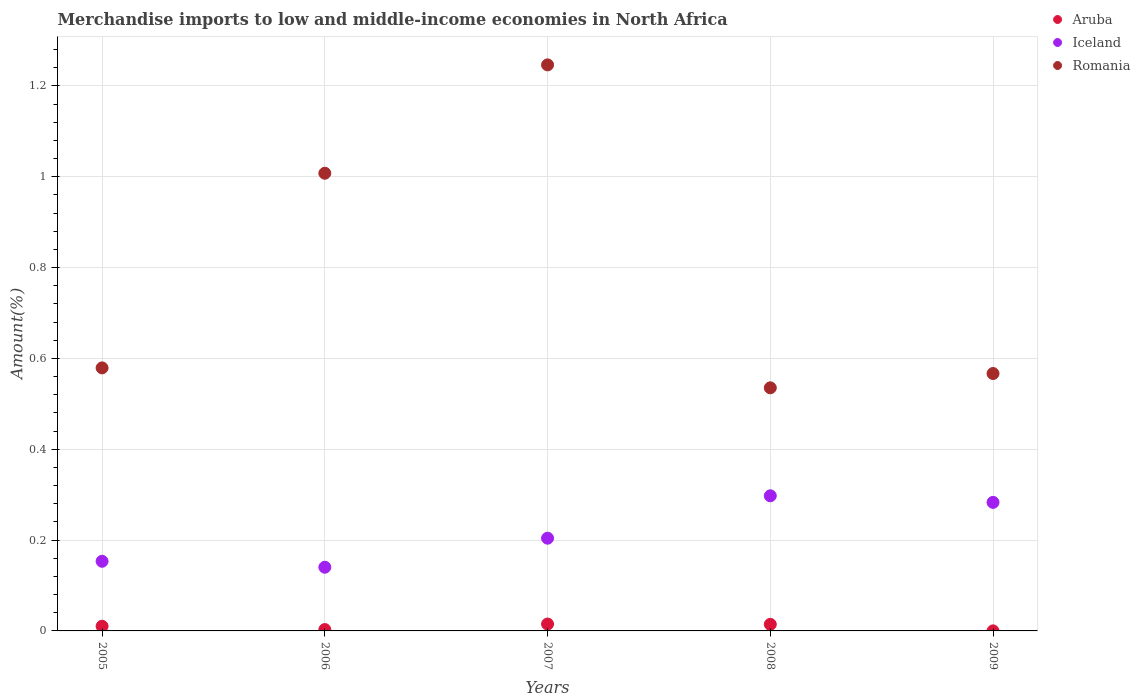How many different coloured dotlines are there?
Provide a short and direct response. 3. Is the number of dotlines equal to the number of legend labels?
Your answer should be very brief. Yes. What is the percentage of amount earned from merchandise imports in Aruba in 2008?
Your answer should be compact. 0.01. Across all years, what is the maximum percentage of amount earned from merchandise imports in Iceland?
Ensure brevity in your answer.  0.3. Across all years, what is the minimum percentage of amount earned from merchandise imports in Aruba?
Keep it short and to the point. 0. In which year was the percentage of amount earned from merchandise imports in Aruba maximum?
Give a very brief answer. 2007. In which year was the percentage of amount earned from merchandise imports in Romania minimum?
Your answer should be compact. 2008. What is the total percentage of amount earned from merchandise imports in Aruba in the graph?
Provide a short and direct response. 0.04. What is the difference between the percentage of amount earned from merchandise imports in Aruba in 2005 and that in 2009?
Your response must be concise. 0.01. What is the difference between the percentage of amount earned from merchandise imports in Iceland in 2006 and the percentage of amount earned from merchandise imports in Romania in 2007?
Your response must be concise. -1.11. What is the average percentage of amount earned from merchandise imports in Romania per year?
Provide a succinct answer. 0.79. In the year 2007, what is the difference between the percentage of amount earned from merchandise imports in Romania and percentage of amount earned from merchandise imports in Aruba?
Keep it short and to the point. 1.23. In how many years, is the percentage of amount earned from merchandise imports in Romania greater than 0.52 %?
Provide a short and direct response. 5. What is the ratio of the percentage of amount earned from merchandise imports in Romania in 2005 to that in 2006?
Provide a short and direct response. 0.57. Is the difference between the percentage of amount earned from merchandise imports in Romania in 2005 and 2007 greater than the difference between the percentage of amount earned from merchandise imports in Aruba in 2005 and 2007?
Give a very brief answer. No. What is the difference between the highest and the second highest percentage of amount earned from merchandise imports in Aruba?
Offer a very short reply. 0. What is the difference between the highest and the lowest percentage of amount earned from merchandise imports in Aruba?
Your answer should be very brief. 0.02. Is the sum of the percentage of amount earned from merchandise imports in Iceland in 2007 and 2008 greater than the maximum percentage of amount earned from merchandise imports in Aruba across all years?
Offer a very short reply. Yes. Is it the case that in every year, the sum of the percentage of amount earned from merchandise imports in Iceland and percentage of amount earned from merchandise imports in Aruba  is greater than the percentage of amount earned from merchandise imports in Romania?
Your answer should be compact. No. Is the percentage of amount earned from merchandise imports in Aruba strictly greater than the percentage of amount earned from merchandise imports in Iceland over the years?
Provide a short and direct response. No. Is the percentage of amount earned from merchandise imports in Romania strictly less than the percentage of amount earned from merchandise imports in Iceland over the years?
Provide a short and direct response. No. How many dotlines are there?
Your answer should be compact. 3. What is the difference between two consecutive major ticks on the Y-axis?
Give a very brief answer. 0.2. Are the values on the major ticks of Y-axis written in scientific E-notation?
Your response must be concise. No. Does the graph contain any zero values?
Offer a terse response. No. Where does the legend appear in the graph?
Make the answer very short. Top right. How are the legend labels stacked?
Make the answer very short. Vertical. What is the title of the graph?
Your response must be concise. Merchandise imports to low and middle-income economies in North Africa. Does "Central African Republic" appear as one of the legend labels in the graph?
Ensure brevity in your answer.  No. What is the label or title of the Y-axis?
Provide a succinct answer. Amount(%). What is the Amount(%) in Aruba in 2005?
Keep it short and to the point. 0.01. What is the Amount(%) of Iceland in 2005?
Your answer should be compact. 0.15. What is the Amount(%) in Romania in 2005?
Ensure brevity in your answer.  0.58. What is the Amount(%) of Aruba in 2006?
Offer a terse response. 0. What is the Amount(%) of Iceland in 2006?
Offer a terse response. 0.14. What is the Amount(%) of Romania in 2006?
Ensure brevity in your answer.  1.01. What is the Amount(%) of Aruba in 2007?
Offer a terse response. 0.02. What is the Amount(%) of Iceland in 2007?
Keep it short and to the point. 0.2. What is the Amount(%) of Romania in 2007?
Your answer should be very brief. 1.25. What is the Amount(%) of Aruba in 2008?
Provide a short and direct response. 0.01. What is the Amount(%) in Iceland in 2008?
Give a very brief answer. 0.3. What is the Amount(%) of Romania in 2008?
Provide a succinct answer. 0.54. What is the Amount(%) in Aruba in 2009?
Give a very brief answer. 0. What is the Amount(%) in Iceland in 2009?
Your answer should be compact. 0.28. What is the Amount(%) in Romania in 2009?
Ensure brevity in your answer.  0.57. Across all years, what is the maximum Amount(%) of Aruba?
Provide a succinct answer. 0.02. Across all years, what is the maximum Amount(%) of Iceland?
Offer a very short reply. 0.3. Across all years, what is the maximum Amount(%) of Romania?
Give a very brief answer. 1.25. Across all years, what is the minimum Amount(%) of Aruba?
Your answer should be compact. 0. Across all years, what is the minimum Amount(%) in Iceland?
Provide a short and direct response. 0.14. Across all years, what is the minimum Amount(%) of Romania?
Offer a terse response. 0.54. What is the total Amount(%) of Aruba in the graph?
Provide a short and direct response. 0.04. What is the total Amount(%) of Iceland in the graph?
Provide a succinct answer. 1.08. What is the total Amount(%) of Romania in the graph?
Your answer should be compact. 3.93. What is the difference between the Amount(%) of Aruba in 2005 and that in 2006?
Give a very brief answer. 0.01. What is the difference between the Amount(%) in Iceland in 2005 and that in 2006?
Your answer should be very brief. 0.01. What is the difference between the Amount(%) in Romania in 2005 and that in 2006?
Provide a succinct answer. -0.43. What is the difference between the Amount(%) in Aruba in 2005 and that in 2007?
Give a very brief answer. -0. What is the difference between the Amount(%) in Iceland in 2005 and that in 2007?
Provide a succinct answer. -0.05. What is the difference between the Amount(%) in Romania in 2005 and that in 2007?
Your answer should be compact. -0.67. What is the difference between the Amount(%) in Aruba in 2005 and that in 2008?
Your response must be concise. -0. What is the difference between the Amount(%) of Iceland in 2005 and that in 2008?
Your answer should be very brief. -0.14. What is the difference between the Amount(%) of Romania in 2005 and that in 2008?
Ensure brevity in your answer.  0.04. What is the difference between the Amount(%) of Aruba in 2005 and that in 2009?
Make the answer very short. 0.01. What is the difference between the Amount(%) of Iceland in 2005 and that in 2009?
Give a very brief answer. -0.13. What is the difference between the Amount(%) in Romania in 2005 and that in 2009?
Make the answer very short. 0.01. What is the difference between the Amount(%) of Aruba in 2006 and that in 2007?
Make the answer very short. -0.01. What is the difference between the Amount(%) of Iceland in 2006 and that in 2007?
Keep it short and to the point. -0.06. What is the difference between the Amount(%) of Romania in 2006 and that in 2007?
Offer a very short reply. -0.24. What is the difference between the Amount(%) of Aruba in 2006 and that in 2008?
Your answer should be compact. -0.01. What is the difference between the Amount(%) of Iceland in 2006 and that in 2008?
Keep it short and to the point. -0.16. What is the difference between the Amount(%) in Romania in 2006 and that in 2008?
Give a very brief answer. 0.47. What is the difference between the Amount(%) of Aruba in 2006 and that in 2009?
Your response must be concise. 0. What is the difference between the Amount(%) of Iceland in 2006 and that in 2009?
Your answer should be very brief. -0.14. What is the difference between the Amount(%) of Romania in 2006 and that in 2009?
Keep it short and to the point. 0.44. What is the difference between the Amount(%) in Aruba in 2007 and that in 2008?
Provide a short and direct response. 0. What is the difference between the Amount(%) of Iceland in 2007 and that in 2008?
Your response must be concise. -0.09. What is the difference between the Amount(%) in Romania in 2007 and that in 2008?
Keep it short and to the point. 0.71. What is the difference between the Amount(%) in Aruba in 2007 and that in 2009?
Provide a short and direct response. 0.02. What is the difference between the Amount(%) in Iceland in 2007 and that in 2009?
Your response must be concise. -0.08. What is the difference between the Amount(%) of Romania in 2007 and that in 2009?
Keep it short and to the point. 0.68. What is the difference between the Amount(%) of Aruba in 2008 and that in 2009?
Give a very brief answer. 0.01. What is the difference between the Amount(%) of Iceland in 2008 and that in 2009?
Provide a short and direct response. 0.01. What is the difference between the Amount(%) in Romania in 2008 and that in 2009?
Ensure brevity in your answer.  -0.03. What is the difference between the Amount(%) of Aruba in 2005 and the Amount(%) of Iceland in 2006?
Offer a very short reply. -0.13. What is the difference between the Amount(%) of Aruba in 2005 and the Amount(%) of Romania in 2006?
Offer a very short reply. -1. What is the difference between the Amount(%) of Iceland in 2005 and the Amount(%) of Romania in 2006?
Your answer should be compact. -0.85. What is the difference between the Amount(%) in Aruba in 2005 and the Amount(%) in Iceland in 2007?
Make the answer very short. -0.19. What is the difference between the Amount(%) in Aruba in 2005 and the Amount(%) in Romania in 2007?
Provide a succinct answer. -1.24. What is the difference between the Amount(%) in Iceland in 2005 and the Amount(%) in Romania in 2007?
Make the answer very short. -1.09. What is the difference between the Amount(%) in Aruba in 2005 and the Amount(%) in Iceland in 2008?
Provide a short and direct response. -0.29. What is the difference between the Amount(%) of Aruba in 2005 and the Amount(%) of Romania in 2008?
Offer a very short reply. -0.52. What is the difference between the Amount(%) of Iceland in 2005 and the Amount(%) of Romania in 2008?
Give a very brief answer. -0.38. What is the difference between the Amount(%) in Aruba in 2005 and the Amount(%) in Iceland in 2009?
Ensure brevity in your answer.  -0.27. What is the difference between the Amount(%) of Aruba in 2005 and the Amount(%) of Romania in 2009?
Offer a very short reply. -0.56. What is the difference between the Amount(%) in Iceland in 2005 and the Amount(%) in Romania in 2009?
Your answer should be very brief. -0.41. What is the difference between the Amount(%) in Aruba in 2006 and the Amount(%) in Iceland in 2007?
Give a very brief answer. -0.2. What is the difference between the Amount(%) in Aruba in 2006 and the Amount(%) in Romania in 2007?
Your answer should be compact. -1.24. What is the difference between the Amount(%) in Iceland in 2006 and the Amount(%) in Romania in 2007?
Provide a short and direct response. -1.11. What is the difference between the Amount(%) of Aruba in 2006 and the Amount(%) of Iceland in 2008?
Your answer should be compact. -0.29. What is the difference between the Amount(%) in Aruba in 2006 and the Amount(%) in Romania in 2008?
Provide a short and direct response. -0.53. What is the difference between the Amount(%) of Iceland in 2006 and the Amount(%) of Romania in 2008?
Make the answer very short. -0.4. What is the difference between the Amount(%) in Aruba in 2006 and the Amount(%) in Iceland in 2009?
Provide a succinct answer. -0.28. What is the difference between the Amount(%) of Aruba in 2006 and the Amount(%) of Romania in 2009?
Offer a terse response. -0.56. What is the difference between the Amount(%) in Iceland in 2006 and the Amount(%) in Romania in 2009?
Offer a very short reply. -0.43. What is the difference between the Amount(%) of Aruba in 2007 and the Amount(%) of Iceland in 2008?
Offer a terse response. -0.28. What is the difference between the Amount(%) of Aruba in 2007 and the Amount(%) of Romania in 2008?
Keep it short and to the point. -0.52. What is the difference between the Amount(%) of Iceland in 2007 and the Amount(%) of Romania in 2008?
Your response must be concise. -0.33. What is the difference between the Amount(%) in Aruba in 2007 and the Amount(%) in Iceland in 2009?
Give a very brief answer. -0.27. What is the difference between the Amount(%) in Aruba in 2007 and the Amount(%) in Romania in 2009?
Your response must be concise. -0.55. What is the difference between the Amount(%) of Iceland in 2007 and the Amount(%) of Romania in 2009?
Keep it short and to the point. -0.36. What is the difference between the Amount(%) of Aruba in 2008 and the Amount(%) of Iceland in 2009?
Your answer should be very brief. -0.27. What is the difference between the Amount(%) in Aruba in 2008 and the Amount(%) in Romania in 2009?
Offer a very short reply. -0.55. What is the difference between the Amount(%) in Iceland in 2008 and the Amount(%) in Romania in 2009?
Offer a terse response. -0.27. What is the average Amount(%) of Aruba per year?
Make the answer very short. 0.01. What is the average Amount(%) of Iceland per year?
Your answer should be compact. 0.22. What is the average Amount(%) of Romania per year?
Provide a succinct answer. 0.79. In the year 2005, what is the difference between the Amount(%) in Aruba and Amount(%) in Iceland?
Your answer should be very brief. -0.14. In the year 2005, what is the difference between the Amount(%) in Aruba and Amount(%) in Romania?
Ensure brevity in your answer.  -0.57. In the year 2005, what is the difference between the Amount(%) in Iceland and Amount(%) in Romania?
Keep it short and to the point. -0.43. In the year 2006, what is the difference between the Amount(%) of Aruba and Amount(%) of Iceland?
Give a very brief answer. -0.14. In the year 2006, what is the difference between the Amount(%) in Aruba and Amount(%) in Romania?
Give a very brief answer. -1. In the year 2006, what is the difference between the Amount(%) in Iceland and Amount(%) in Romania?
Ensure brevity in your answer.  -0.87. In the year 2007, what is the difference between the Amount(%) of Aruba and Amount(%) of Iceland?
Your answer should be very brief. -0.19. In the year 2007, what is the difference between the Amount(%) in Aruba and Amount(%) in Romania?
Your response must be concise. -1.23. In the year 2007, what is the difference between the Amount(%) of Iceland and Amount(%) of Romania?
Ensure brevity in your answer.  -1.04. In the year 2008, what is the difference between the Amount(%) in Aruba and Amount(%) in Iceland?
Keep it short and to the point. -0.28. In the year 2008, what is the difference between the Amount(%) in Aruba and Amount(%) in Romania?
Make the answer very short. -0.52. In the year 2008, what is the difference between the Amount(%) of Iceland and Amount(%) of Romania?
Keep it short and to the point. -0.24. In the year 2009, what is the difference between the Amount(%) of Aruba and Amount(%) of Iceland?
Your answer should be very brief. -0.28. In the year 2009, what is the difference between the Amount(%) of Aruba and Amount(%) of Romania?
Offer a very short reply. -0.57. In the year 2009, what is the difference between the Amount(%) in Iceland and Amount(%) in Romania?
Provide a short and direct response. -0.28. What is the ratio of the Amount(%) in Aruba in 2005 to that in 2006?
Provide a succinct answer. 3.45. What is the ratio of the Amount(%) of Iceland in 2005 to that in 2006?
Keep it short and to the point. 1.09. What is the ratio of the Amount(%) of Romania in 2005 to that in 2006?
Keep it short and to the point. 0.57. What is the ratio of the Amount(%) in Aruba in 2005 to that in 2007?
Provide a short and direct response. 0.68. What is the ratio of the Amount(%) of Iceland in 2005 to that in 2007?
Keep it short and to the point. 0.75. What is the ratio of the Amount(%) in Romania in 2005 to that in 2007?
Give a very brief answer. 0.46. What is the ratio of the Amount(%) in Aruba in 2005 to that in 2008?
Your response must be concise. 0.71. What is the ratio of the Amount(%) of Iceland in 2005 to that in 2008?
Ensure brevity in your answer.  0.52. What is the ratio of the Amount(%) in Romania in 2005 to that in 2008?
Offer a terse response. 1.08. What is the ratio of the Amount(%) of Aruba in 2005 to that in 2009?
Your answer should be compact. 87.95. What is the ratio of the Amount(%) in Iceland in 2005 to that in 2009?
Make the answer very short. 0.54. What is the ratio of the Amount(%) in Romania in 2005 to that in 2009?
Give a very brief answer. 1.02. What is the ratio of the Amount(%) in Aruba in 2006 to that in 2007?
Offer a very short reply. 0.2. What is the ratio of the Amount(%) of Iceland in 2006 to that in 2007?
Your response must be concise. 0.69. What is the ratio of the Amount(%) in Romania in 2006 to that in 2007?
Your response must be concise. 0.81. What is the ratio of the Amount(%) of Aruba in 2006 to that in 2008?
Give a very brief answer. 0.21. What is the ratio of the Amount(%) in Iceland in 2006 to that in 2008?
Your answer should be compact. 0.47. What is the ratio of the Amount(%) of Romania in 2006 to that in 2008?
Offer a terse response. 1.88. What is the ratio of the Amount(%) in Aruba in 2006 to that in 2009?
Your answer should be very brief. 25.47. What is the ratio of the Amount(%) in Iceland in 2006 to that in 2009?
Ensure brevity in your answer.  0.5. What is the ratio of the Amount(%) of Romania in 2006 to that in 2009?
Offer a very short reply. 1.78. What is the ratio of the Amount(%) in Aruba in 2007 to that in 2008?
Provide a short and direct response. 1.05. What is the ratio of the Amount(%) in Iceland in 2007 to that in 2008?
Give a very brief answer. 0.69. What is the ratio of the Amount(%) of Romania in 2007 to that in 2008?
Provide a short and direct response. 2.33. What is the ratio of the Amount(%) of Aruba in 2007 to that in 2009?
Offer a terse response. 129.29. What is the ratio of the Amount(%) in Iceland in 2007 to that in 2009?
Offer a terse response. 0.72. What is the ratio of the Amount(%) in Romania in 2007 to that in 2009?
Your response must be concise. 2.2. What is the ratio of the Amount(%) of Aruba in 2008 to that in 2009?
Offer a terse response. 123.44. What is the ratio of the Amount(%) in Iceland in 2008 to that in 2009?
Keep it short and to the point. 1.05. What is the ratio of the Amount(%) in Romania in 2008 to that in 2009?
Provide a short and direct response. 0.94. What is the difference between the highest and the second highest Amount(%) of Aruba?
Offer a terse response. 0. What is the difference between the highest and the second highest Amount(%) in Iceland?
Keep it short and to the point. 0.01. What is the difference between the highest and the second highest Amount(%) in Romania?
Provide a succinct answer. 0.24. What is the difference between the highest and the lowest Amount(%) in Aruba?
Your answer should be very brief. 0.02. What is the difference between the highest and the lowest Amount(%) in Iceland?
Offer a very short reply. 0.16. What is the difference between the highest and the lowest Amount(%) in Romania?
Provide a short and direct response. 0.71. 